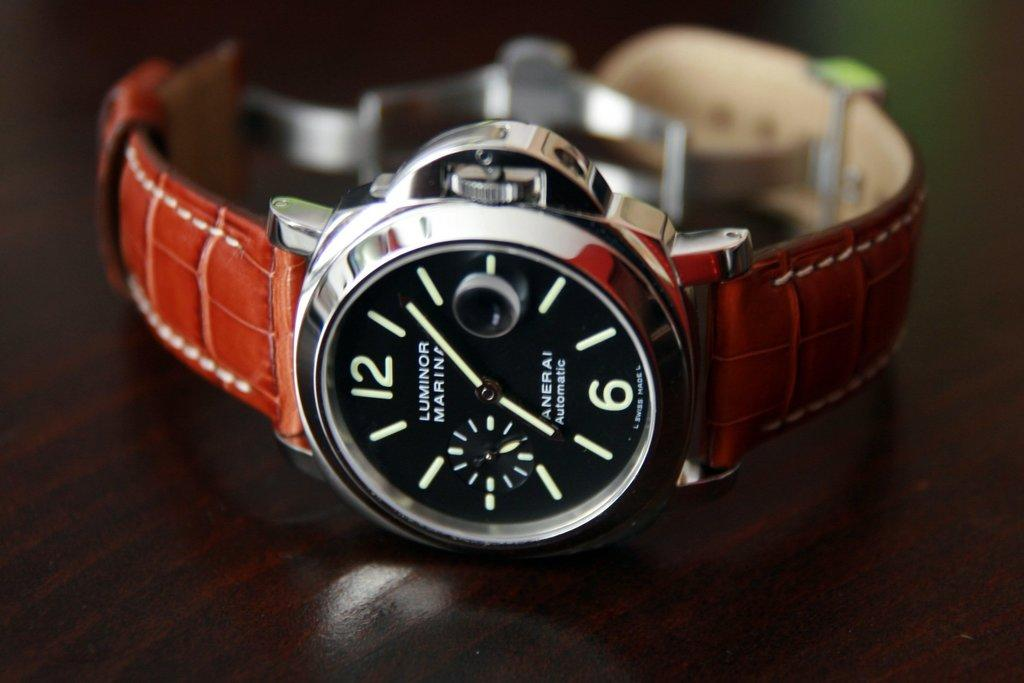<image>
Render a clear and concise summary of the photo. Silver Luminor brand watch with a leather band. 